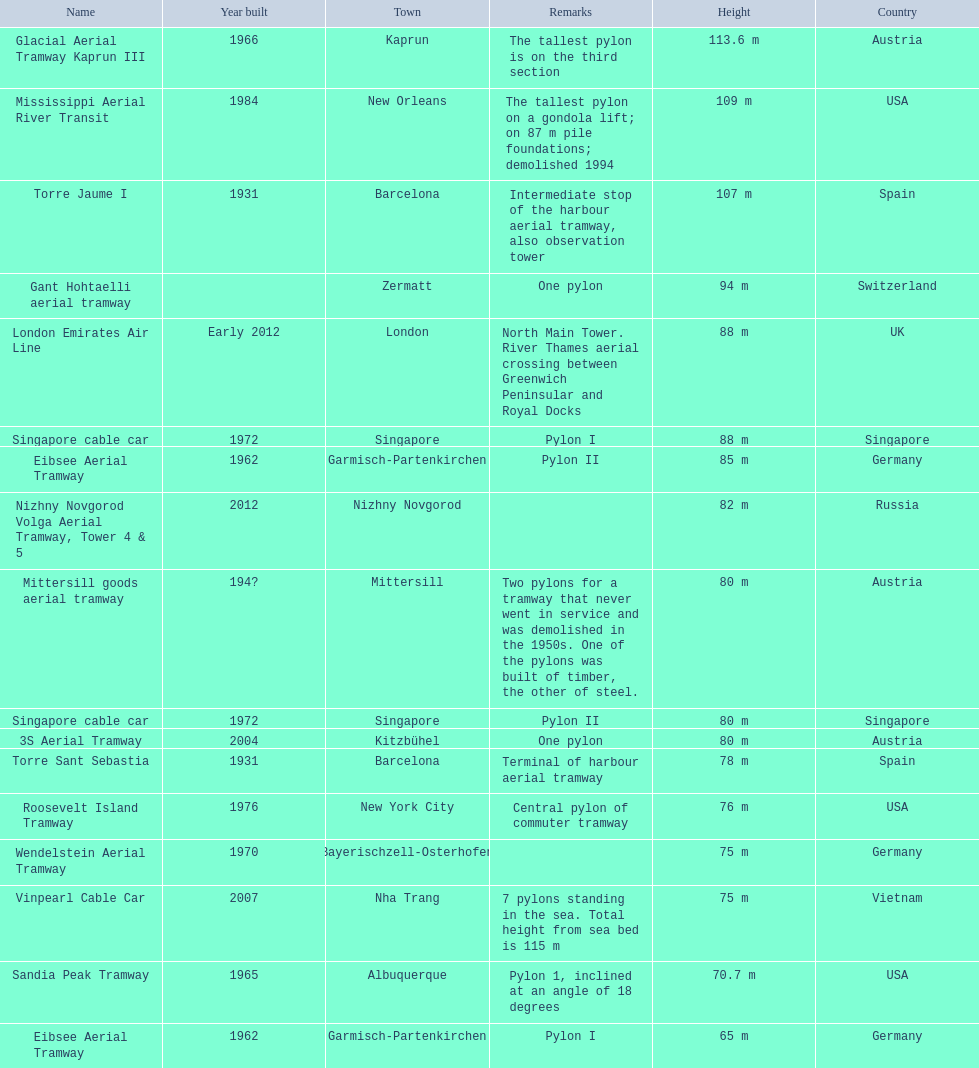What year was the last pylon in germany built? 1970. 